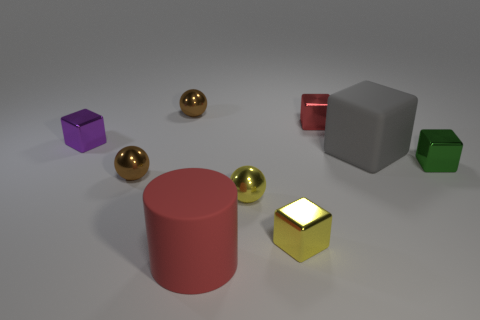Subtract 1 blocks. How many blocks are left? 4 Subtract all red cubes. How many cubes are left? 4 Subtract all tiny green shiny blocks. How many blocks are left? 4 Subtract all blue blocks. Subtract all red spheres. How many blocks are left? 5 Subtract all balls. How many objects are left? 6 Subtract all big brown cylinders. Subtract all red cubes. How many objects are left? 8 Add 4 small red metallic blocks. How many small red metallic blocks are left? 5 Add 5 small brown shiny balls. How many small brown shiny balls exist? 7 Subtract 1 yellow spheres. How many objects are left? 8 